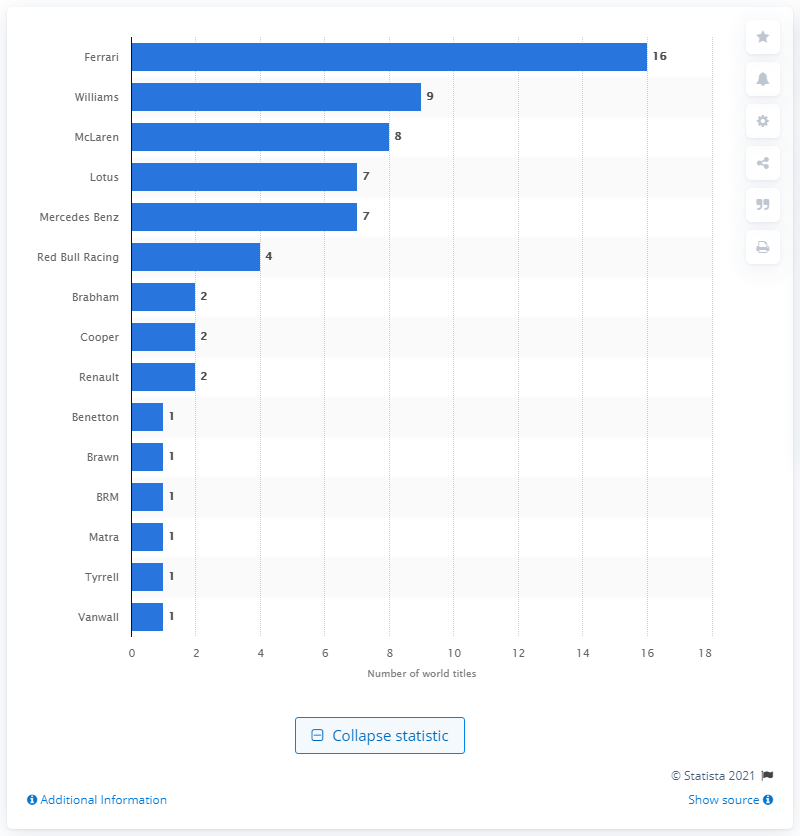Outline some significant characteristics in this image. As of 2021, Ferrari had won a total of 16 championship titles. 